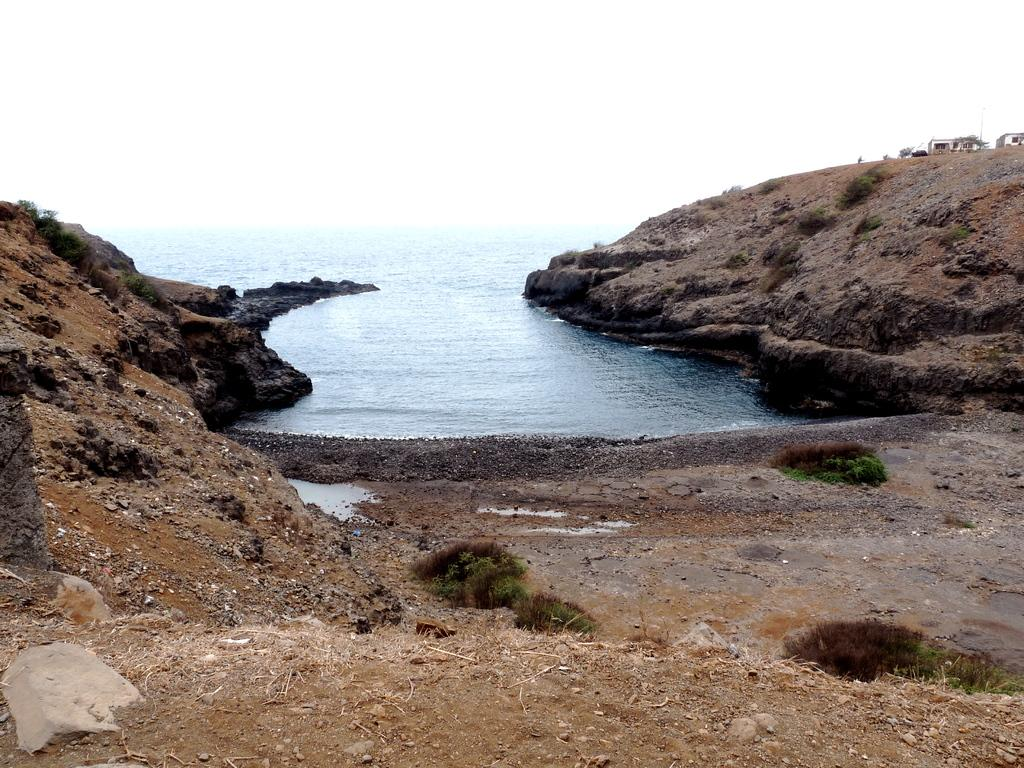What is the primary element in the image? There is a water surface in the image. What type of surface surrounds the water? There is a rock surface around the water. What can be seen in the background of the image? The sky is visible in the background of the image. What direction is the banana facing in the image? There is no banana present in the image. How is the cream incorporated into the water surface in the image? There is no cream present in the image. 